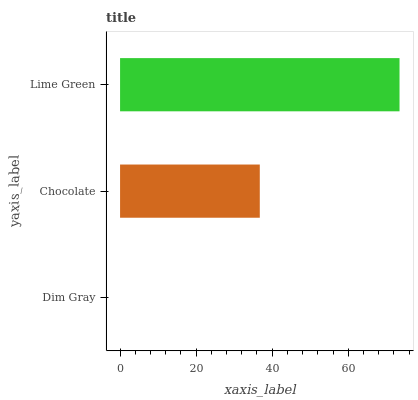Is Dim Gray the minimum?
Answer yes or no. Yes. Is Lime Green the maximum?
Answer yes or no. Yes. Is Chocolate the minimum?
Answer yes or no. No. Is Chocolate the maximum?
Answer yes or no. No. Is Chocolate greater than Dim Gray?
Answer yes or no. Yes. Is Dim Gray less than Chocolate?
Answer yes or no. Yes. Is Dim Gray greater than Chocolate?
Answer yes or no. No. Is Chocolate less than Dim Gray?
Answer yes or no. No. Is Chocolate the high median?
Answer yes or no. Yes. Is Chocolate the low median?
Answer yes or no. Yes. Is Dim Gray the high median?
Answer yes or no. No. Is Lime Green the low median?
Answer yes or no. No. 